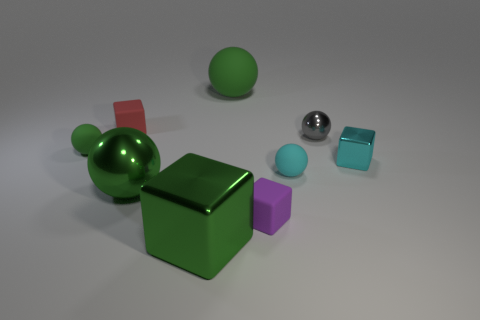There is a metal ball to the right of the tiny cyan sphere; does it have the same color as the small thing that is behind the gray metallic sphere? no 